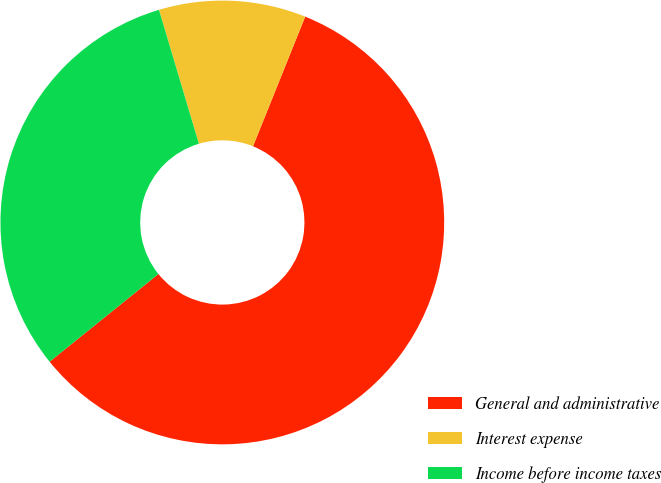Convert chart. <chart><loc_0><loc_0><loc_500><loc_500><pie_chart><fcel>General and administrative<fcel>Interest expense<fcel>Income before income taxes<nl><fcel>58.11%<fcel>10.7%<fcel>31.19%<nl></chart> 